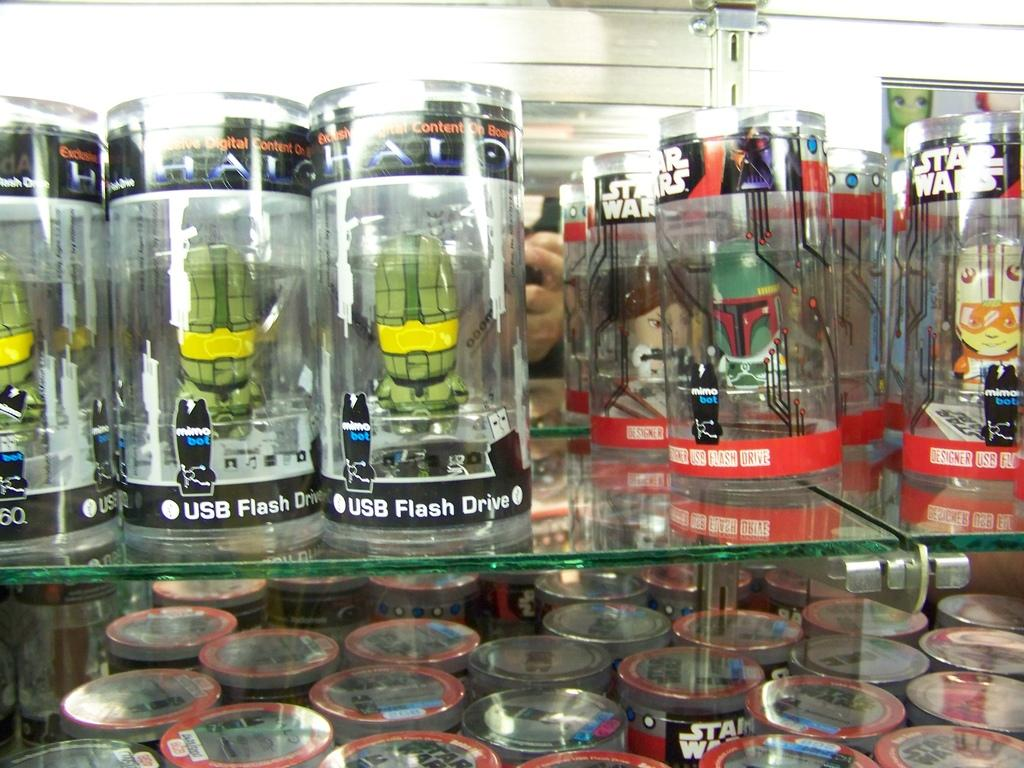Provide a one-sentence caption for the provided image. USB flash drives in clear plastic cylinders are lined up on glass shelves. 